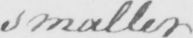What text is written in this handwritten line? smaller 